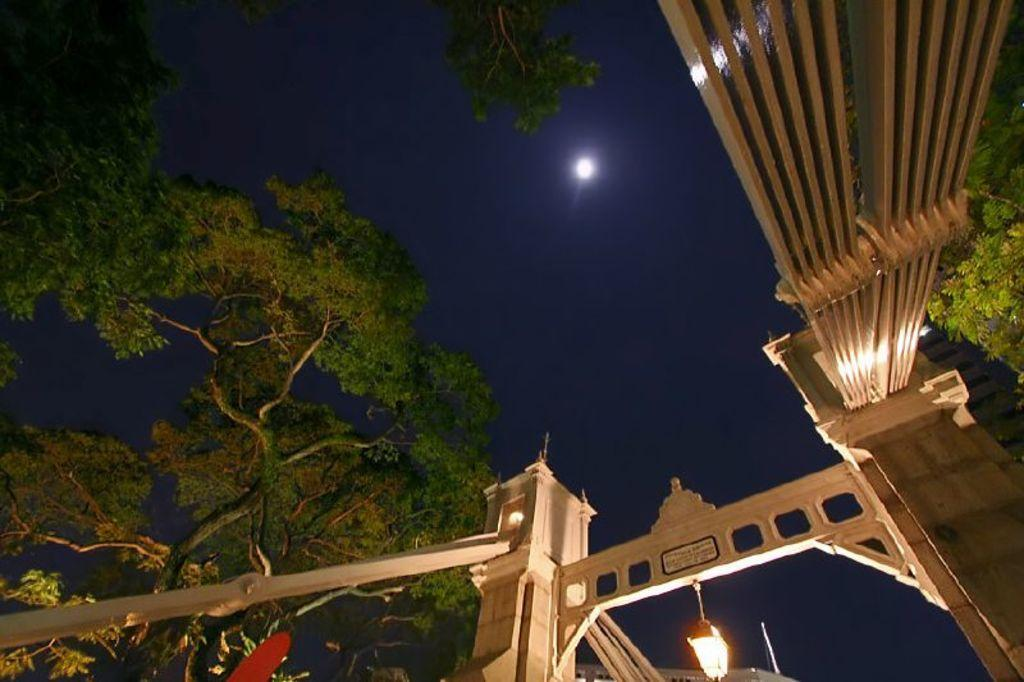What type of natural elements can be seen in the image? There are trees in the image. What artificial elements can be seen in the image? There are lights and pillars in the image. What is visible in the background of the image? The sky and the moon are visible in the background of the image. What type of business is being conducted in the image? There is no indication of any business activity in the image. Can you see any hills in the image? There are no hills visible in the image; it features trees, lights, pillars, and the sky with the moon. 